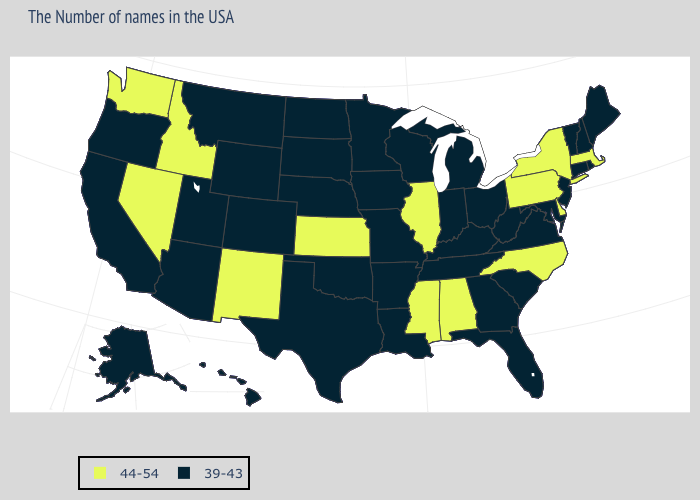What is the value of Delaware?
Quick response, please. 44-54. Name the states that have a value in the range 39-43?
Write a very short answer. Maine, Rhode Island, New Hampshire, Vermont, Connecticut, New Jersey, Maryland, Virginia, South Carolina, West Virginia, Ohio, Florida, Georgia, Michigan, Kentucky, Indiana, Tennessee, Wisconsin, Louisiana, Missouri, Arkansas, Minnesota, Iowa, Nebraska, Oklahoma, Texas, South Dakota, North Dakota, Wyoming, Colorado, Utah, Montana, Arizona, California, Oregon, Alaska, Hawaii. What is the value of Maine?
Give a very brief answer. 39-43. Does Mississippi have the lowest value in the South?
Be succinct. No. Name the states that have a value in the range 39-43?
Short answer required. Maine, Rhode Island, New Hampshire, Vermont, Connecticut, New Jersey, Maryland, Virginia, South Carolina, West Virginia, Ohio, Florida, Georgia, Michigan, Kentucky, Indiana, Tennessee, Wisconsin, Louisiana, Missouri, Arkansas, Minnesota, Iowa, Nebraska, Oklahoma, Texas, South Dakota, North Dakota, Wyoming, Colorado, Utah, Montana, Arizona, California, Oregon, Alaska, Hawaii. Does Idaho have the lowest value in the West?
Write a very short answer. No. Name the states that have a value in the range 39-43?
Answer briefly. Maine, Rhode Island, New Hampshire, Vermont, Connecticut, New Jersey, Maryland, Virginia, South Carolina, West Virginia, Ohio, Florida, Georgia, Michigan, Kentucky, Indiana, Tennessee, Wisconsin, Louisiana, Missouri, Arkansas, Minnesota, Iowa, Nebraska, Oklahoma, Texas, South Dakota, North Dakota, Wyoming, Colorado, Utah, Montana, Arizona, California, Oregon, Alaska, Hawaii. What is the highest value in the West ?
Answer briefly. 44-54. Among the states that border Colorado , which have the highest value?
Keep it brief. Kansas, New Mexico. What is the highest value in the South ?
Answer briefly. 44-54. Name the states that have a value in the range 44-54?
Write a very short answer. Massachusetts, New York, Delaware, Pennsylvania, North Carolina, Alabama, Illinois, Mississippi, Kansas, New Mexico, Idaho, Nevada, Washington. Among the states that border Alabama , does Mississippi have the highest value?
Answer briefly. Yes. What is the highest value in states that border Connecticut?
Quick response, please. 44-54. Name the states that have a value in the range 39-43?
Concise answer only. Maine, Rhode Island, New Hampshire, Vermont, Connecticut, New Jersey, Maryland, Virginia, South Carolina, West Virginia, Ohio, Florida, Georgia, Michigan, Kentucky, Indiana, Tennessee, Wisconsin, Louisiana, Missouri, Arkansas, Minnesota, Iowa, Nebraska, Oklahoma, Texas, South Dakota, North Dakota, Wyoming, Colorado, Utah, Montana, Arizona, California, Oregon, Alaska, Hawaii. Does Kansas have a lower value than Texas?
Be succinct. No. 